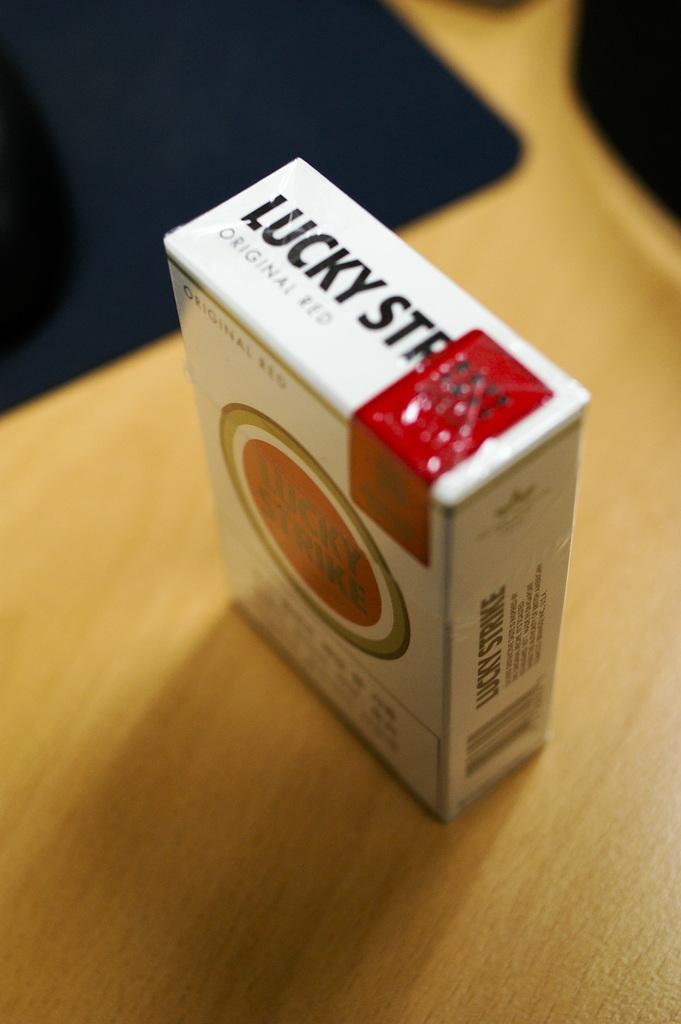What brand of cigarettes is this?
Provide a short and direct response. Lucky strike. 